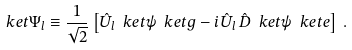Convert formula to latex. <formula><loc_0><loc_0><loc_500><loc_500>\ k e t { \Psi _ { l } } \equiv \frac { 1 } { \sqrt { 2 } } \left [ \hat { U } _ { l } \ k e t { \psi } \ k e t { g } - i \hat { U } _ { l } \, \hat { D } \ k e t { \psi } \ k e t { e } \right ] \, .</formula> 